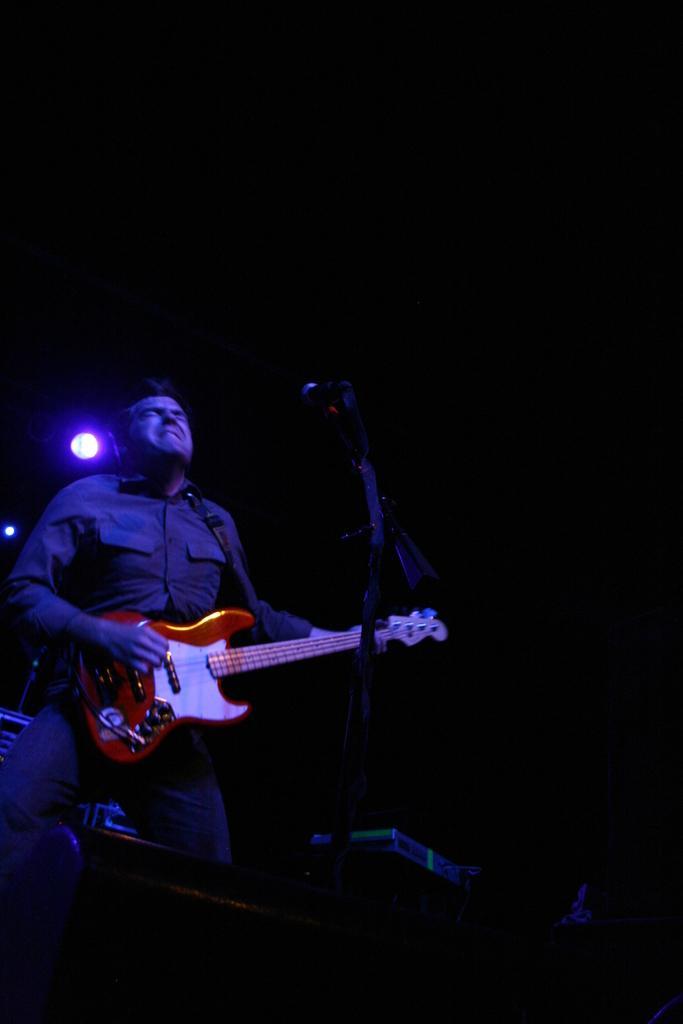In one or two sentences, can you explain what this image depicts? In this image I see a man, who is holding the guitar and standing in front of a mic. In the background I see the light. 